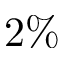<formula> <loc_0><loc_0><loc_500><loc_500>2 \%</formula> 